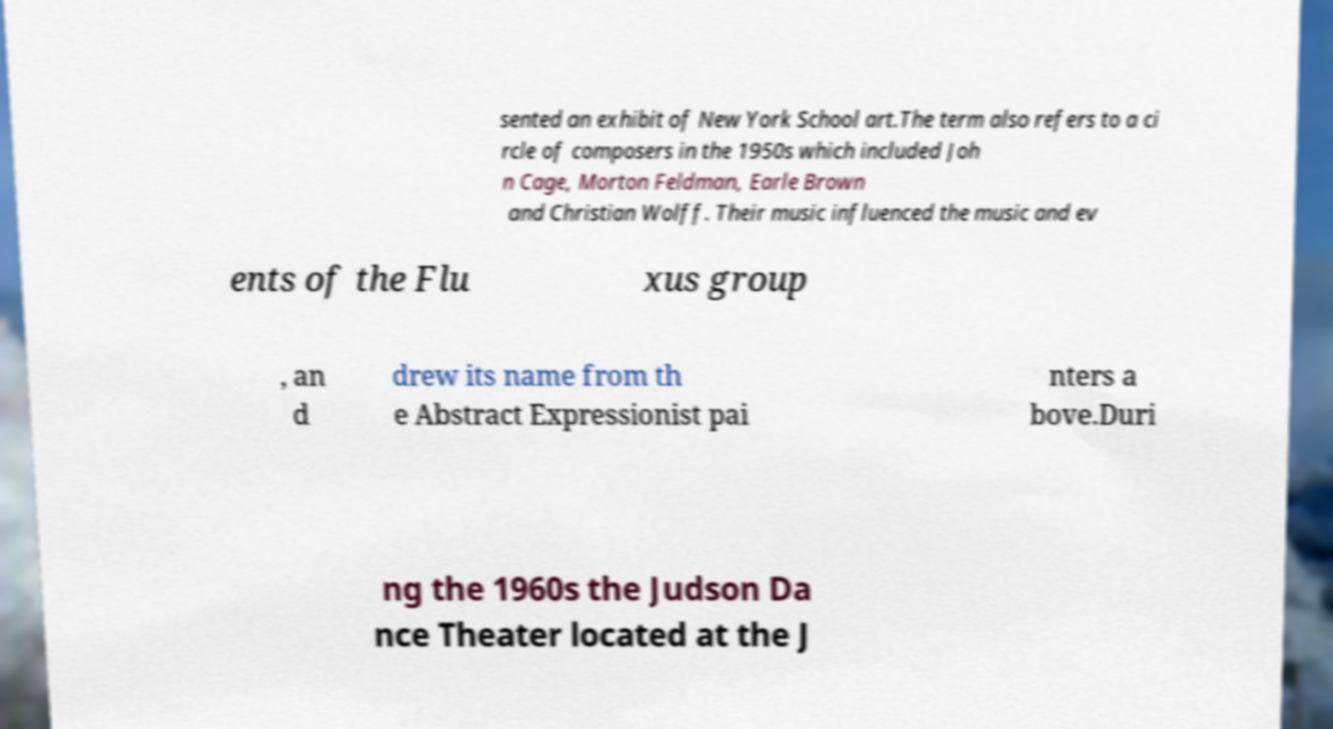Can you accurately transcribe the text from the provided image for me? sented an exhibit of New York School art.The term also refers to a ci rcle of composers in the 1950s which included Joh n Cage, Morton Feldman, Earle Brown and Christian Wolff. Their music influenced the music and ev ents of the Flu xus group , an d drew its name from th e Abstract Expressionist pai nters a bove.Duri ng the 1960s the Judson Da nce Theater located at the J 